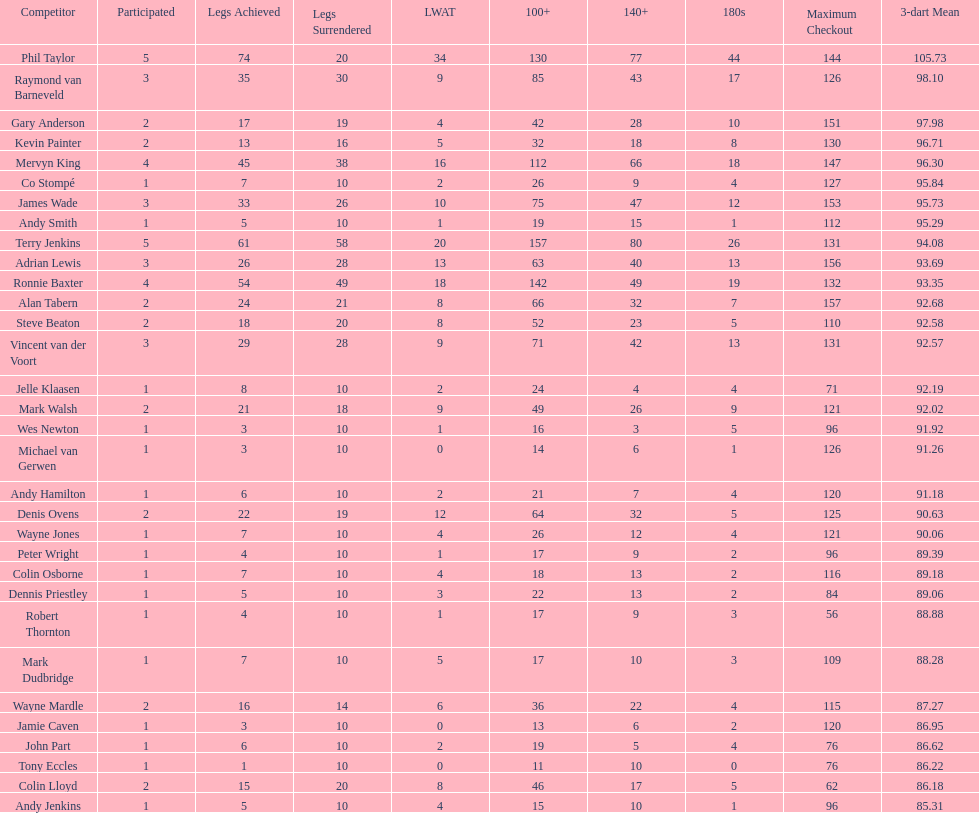List each of the players with a high checkout of 131. Terry Jenkins, Vincent van der Voort. 